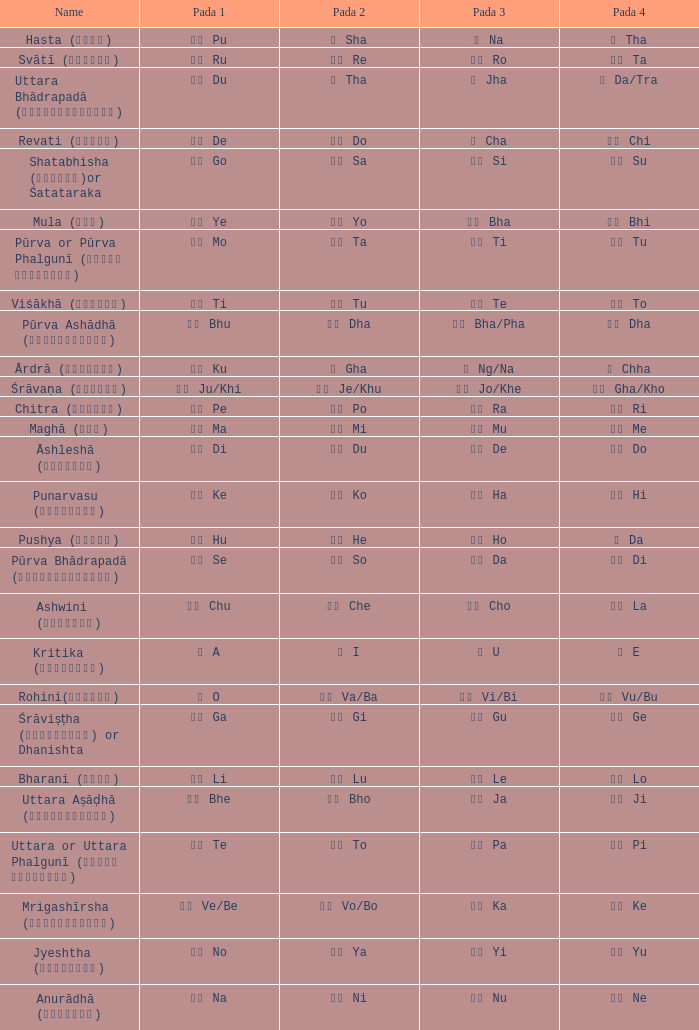What is the Name of ङ ng/na? Ārdrā (आर्द्रा). 